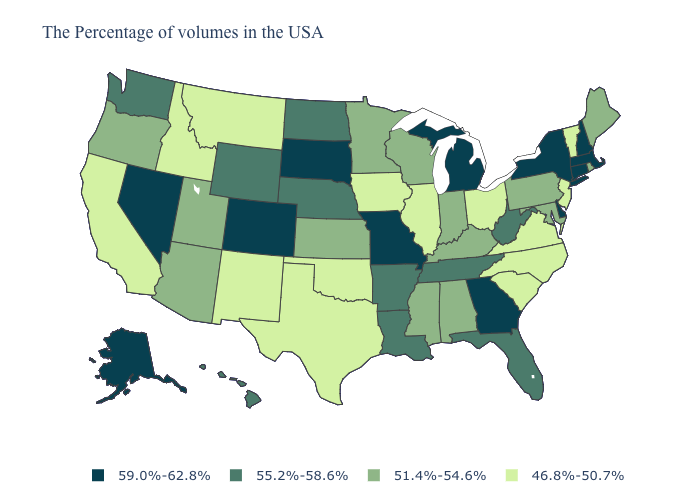Among the states that border Indiana , which have the lowest value?
Be succinct. Ohio, Illinois. What is the value of Ohio?
Give a very brief answer. 46.8%-50.7%. Does Virginia have a lower value than Illinois?
Concise answer only. No. What is the value of Idaho?
Be succinct. 46.8%-50.7%. Name the states that have a value in the range 51.4%-54.6%?
Short answer required. Maine, Rhode Island, Maryland, Pennsylvania, Kentucky, Indiana, Alabama, Wisconsin, Mississippi, Minnesota, Kansas, Utah, Arizona, Oregon. Which states have the lowest value in the West?
Be succinct. New Mexico, Montana, Idaho, California. Name the states that have a value in the range 55.2%-58.6%?
Quick response, please. West Virginia, Florida, Tennessee, Louisiana, Arkansas, Nebraska, North Dakota, Wyoming, Washington, Hawaii. What is the value of Nebraska?
Answer briefly. 55.2%-58.6%. What is the value of Tennessee?
Quick response, please. 55.2%-58.6%. Among the states that border Utah , does New Mexico have the lowest value?
Keep it brief. Yes. What is the highest value in the MidWest ?
Give a very brief answer. 59.0%-62.8%. Among the states that border Wisconsin , which have the highest value?
Short answer required. Michigan. What is the lowest value in the Northeast?
Answer briefly. 46.8%-50.7%. Does Oregon have a higher value than New Jersey?
Write a very short answer. Yes. Name the states that have a value in the range 51.4%-54.6%?
Keep it brief. Maine, Rhode Island, Maryland, Pennsylvania, Kentucky, Indiana, Alabama, Wisconsin, Mississippi, Minnesota, Kansas, Utah, Arizona, Oregon. 